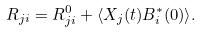Convert formula to latex. <formula><loc_0><loc_0><loc_500><loc_500>R _ { j i } = R _ { j i } ^ { 0 } + \langle X _ { j } ( t ) B _ { i } ^ { * } ( 0 ) \rangle .</formula> 